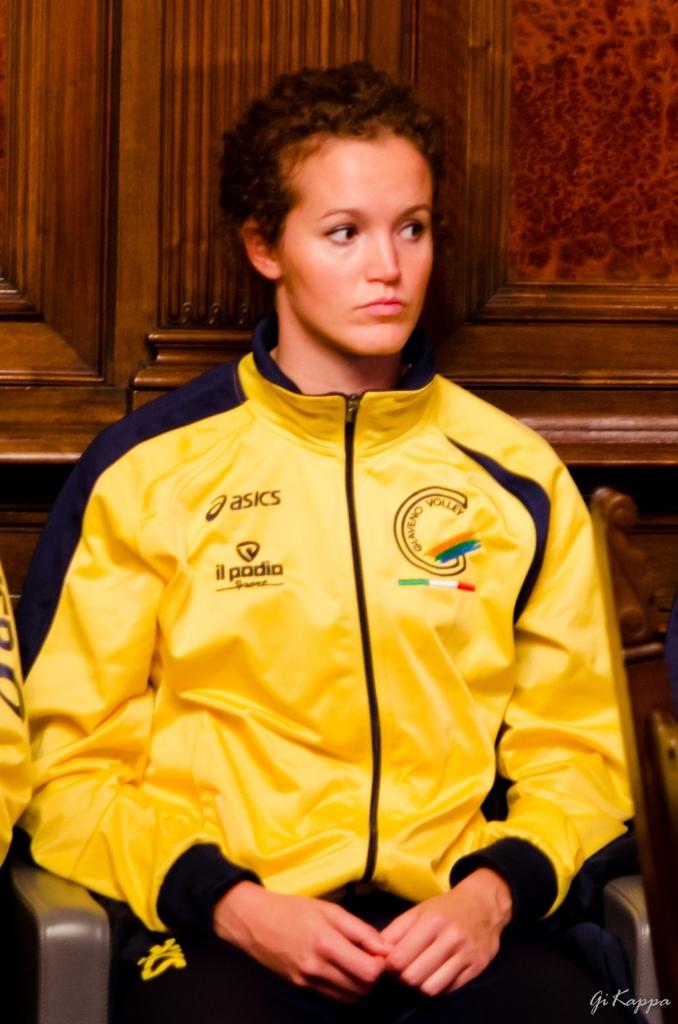What company makes this jacket?
Make the answer very short. Asics. 